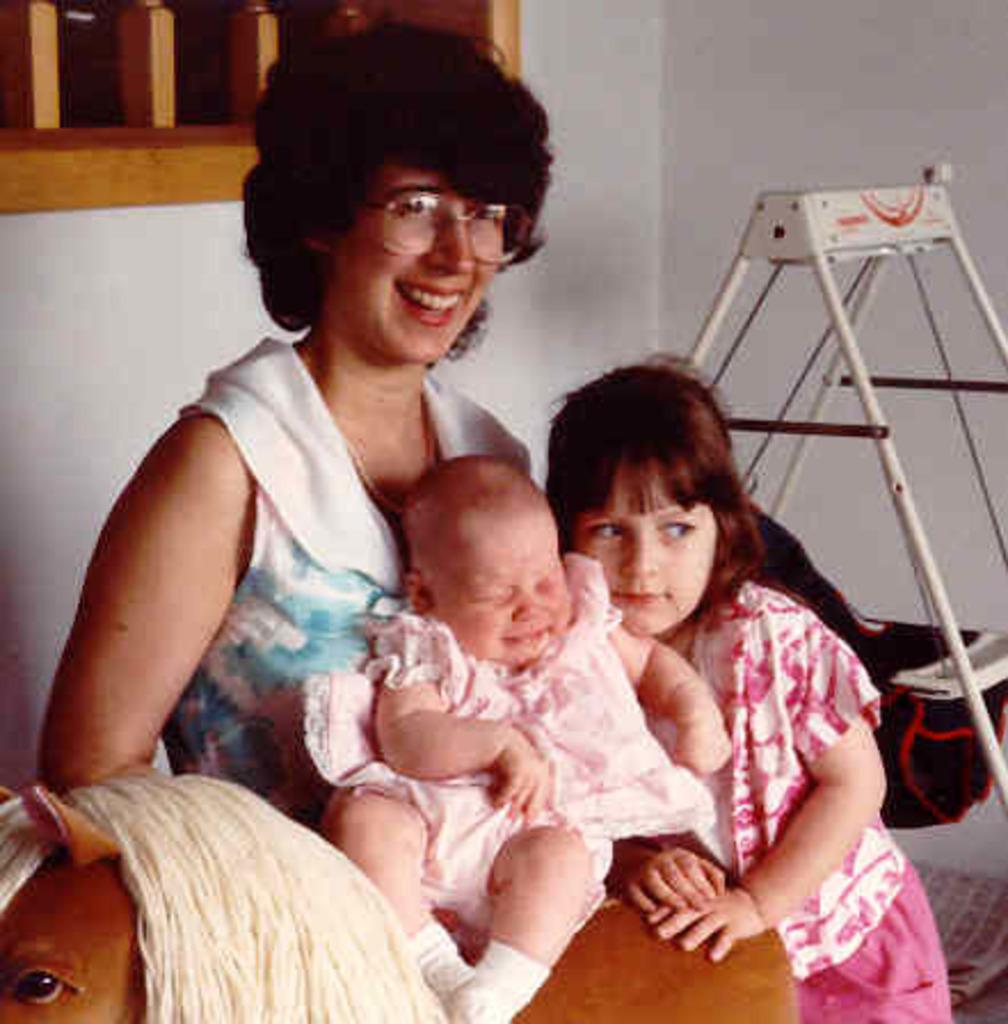What is the woman doing in the image? The woman is sitting near the wall in the image. What is the girl doing in the image? The girl is standing and holding a toy in the image. What is the baby doing in the image? The baby is sitting on the toy in the image. What type of window is present in the image? There is a wooden window in the image. What can be found on the floor in the image? There are objects on the floor in the image. What type of house is shown in the image? There is no house shown in the image; it only features a woman, a girl, a baby, a wooden window, and objects on the floor. 